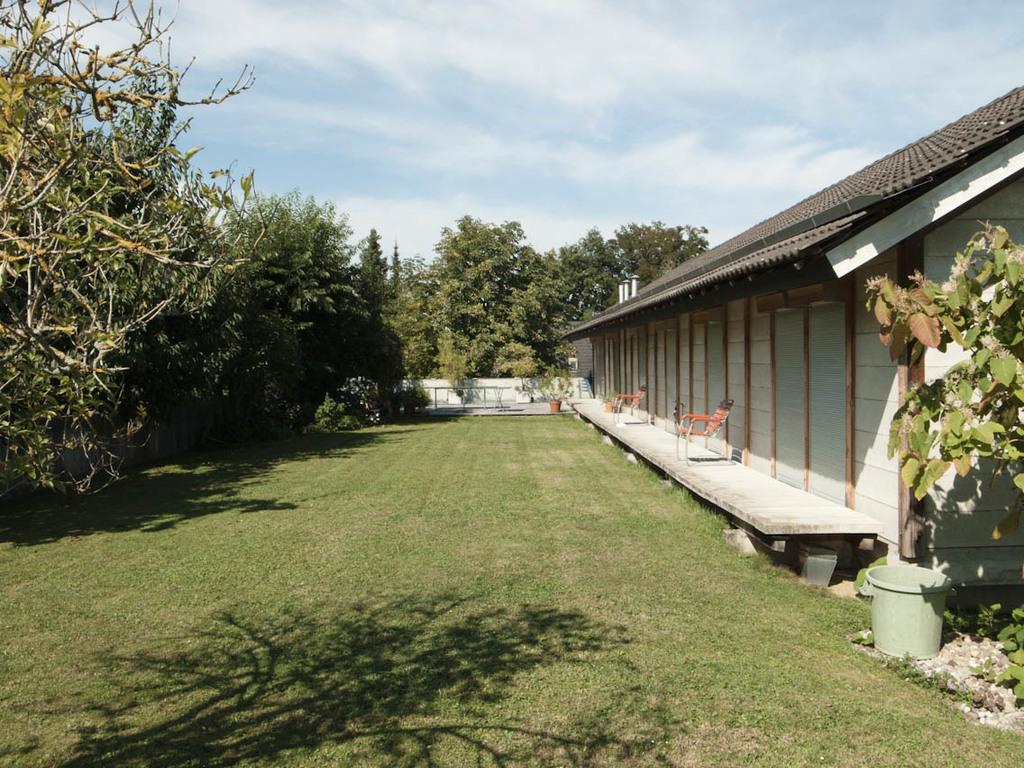Please provide a concise description of this image. This is the picture of a place where we have a house and around there are some trees, plants, grass, chairs on the floor. 